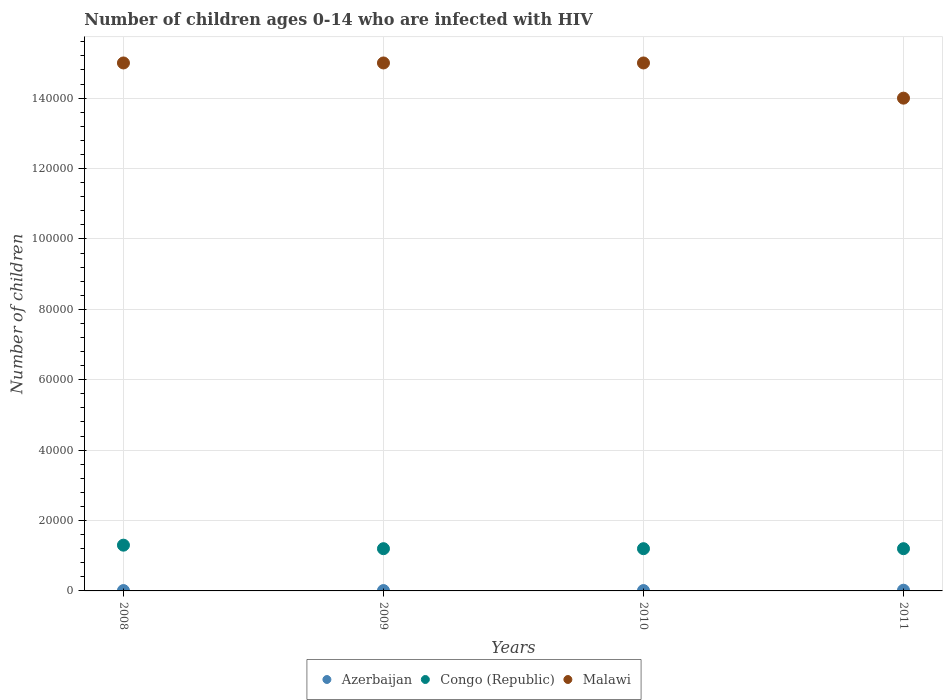What is the number of HIV infected children in Congo (Republic) in 2010?
Provide a succinct answer. 1.20e+04. Across all years, what is the maximum number of HIV infected children in Malawi?
Give a very brief answer. 1.50e+05. Across all years, what is the minimum number of HIV infected children in Congo (Republic)?
Provide a short and direct response. 1.20e+04. In which year was the number of HIV infected children in Congo (Republic) maximum?
Make the answer very short. 2008. In which year was the number of HIV infected children in Malawi minimum?
Provide a short and direct response. 2011. What is the total number of HIV infected children in Malawi in the graph?
Ensure brevity in your answer.  5.90e+05. What is the difference between the number of HIV infected children in Azerbaijan in 2011 and the number of HIV infected children in Malawi in 2010?
Make the answer very short. -1.50e+05. What is the average number of HIV infected children in Azerbaijan per year?
Provide a succinct answer. 125. In the year 2010, what is the difference between the number of HIV infected children in Malawi and number of HIV infected children in Azerbaijan?
Provide a succinct answer. 1.50e+05. What is the ratio of the number of HIV infected children in Malawi in 2009 to that in 2010?
Your response must be concise. 1. Is the number of HIV infected children in Malawi in 2008 less than that in 2010?
Give a very brief answer. No. What is the difference between the highest and the lowest number of HIV infected children in Congo (Republic)?
Provide a short and direct response. 1000. Is it the case that in every year, the sum of the number of HIV infected children in Azerbaijan and number of HIV infected children in Congo (Republic)  is greater than the number of HIV infected children in Malawi?
Give a very brief answer. No. Is the number of HIV infected children in Azerbaijan strictly greater than the number of HIV infected children in Malawi over the years?
Provide a succinct answer. No. How many years are there in the graph?
Offer a very short reply. 4. What is the difference between two consecutive major ticks on the Y-axis?
Your answer should be compact. 2.00e+04. What is the title of the graph?
Keep it short and to the point. Number of children ages 0-14 who are infected with HIV. Does "Equatorial Guinea" appear as one of the legend labels in the graph?
Ensure brevity in your answer.  No. What is the label or title of the X-axis?
Your answer should be compact. Years. What is the label or title of the Y-axis?
Keep it short and to the point. Number of children. What is the Number of children in Azerbaijan in 2008?
Provide a short and direct response. 100. What is the Number of children of Congo (Republic) in 2008?
Your answer should be very brief. 1.30e+04. What is the Number of children of Azerbaijan in 2009?
Keep it short and to the point. 100. What is the Number of children of Congo (Republic) in 2009?
Give a very brief answer. 1.20e+04. What is the Number of children in Azerbaijan in 2010?
Offer a very short reply. 100. What is the Number of children of Congo (Republic) in 2010?
Keep it short and to the point. 1.20e+04. What is the Number of children of Malawi in 2010?
Provide a succinct answer. 1.50e+05. What is the Number of children of Azerbaijan in 2011?
Provide a short and direct response. 200. What is the Number of children in Congo (Republic) in 2011?
Keep it short and to the point. 1.20e+04. Across all years, what is the maximum Number of children in Azerbaijan?
Keep it short and to the point. 200. Across all years, what is the maximum Number of children in Congo (Republic)?
Keep it short and to the point. 1.30e+04. Across all years, what is the maximum Number of children in Malawi?
Your answer should be compact. 1.50e+05. Across all years, what is the minimum Number of children of Azerbaijan?
Give a very brief answer. 100. Across all years, what is the minimum Number of children of Congo (Republic)?
Provide a succinct answer. 1.20e+04. Across all years, what is the minimum Number of children of Malawi?
Your response must be concise. 1.40e+05. What is the total Number of children in Congo (Republic) in the graph?
Make the answer very short. 4.90e+04. What is the total Number of children in Malawi in the graph?
Give a very brief answer. 5.90e+05. What is the difference between the Number of children of Azerbaijan in 2008 and that in 2009?
Ensure brevity in your answer.  0. What is the difference between the Number of children in Malawi in 2008 and that in 2009?
Offer a terse response. 0. What is the difference between the Number of children of Congo (Republic) in 2008 and that in 2010?
Provide a succinct answer. 1000. What is the difference between the Number of children of Malawi in 2008 and that in 2010?
Keep it short and to the point. 0. What is the difference between the Number of children of Azerbaijan in 2008 and that in 2011?
Your response must be concise. -100. What is the difference between the Number of children in Congo (Republic) in 2008 and that in 2011?
Ensure brevity in your answer.  1000. What is the difference between the Number of children of Malawi in 2008 and that in 2011?
Make the answer very short. 10000. What is the difference between the Number of children in Azerbaijan in 2009 and that in 2010?
Offer a terse response. 0. What is the difference between the Number of children in Malawi in 2009 and that in 2010?
Keep it short and to the point. 0. What is the difference between the Number of children of Azerbaijan in 2009 and that in 2011?
Make the answer very short. -100. What is the difference between the Number of children in Congo (Republic) in 2009 and that in 2011?
Provide a short and direct response. 0. What is the difference between the Number of children in Azerbaijan in 2010 and that in 2011?
Provide a succinct answer. -100. What is the difference between the Number of children of Congo (Republic) in 2010 and that in 2011?
Provide a succinct answer. 0. What is the difference between the Number of children in Azerbaijan in 2008 and the Number of children in Congo (Republic) in 2009?
Your answer should be very brief. -1.19e+04. What is the difference between the Number of children in Azerbaijan in 2008 and the Number of children in Malawi in 2009?
Provide a succinct answer. -1.50e+05. What is the difference between the Number of children in Congo (Republic) in 2008 and the Number of children in Malawi in 2009?
Keep it short and to the point. -1.37e+05. What is the difference between the Number of children of Azerbaijan in 2008 and the Number of children of Congo (Republic) in 2010?
Offer a very short reply. -1.19e+04. What is the difference between the Number of children in Azerbaijan in 2008 and the Number of children in Malawi in 2010?
Make the answer very short. -1.50e+05. What is the difference between the Number of children in Congo (Republic) in 2008 and the Number of children in Malawi in 2010?
Keep it short and to the point. -1.37e+05. What is the difference between the Number of children of Azerbaijan in 2008 and the Number of children of Congo (Republic) in 2011?
Make the answer very short. -1.19e+04. What is the difference between the Number of children of Azerbaijan in 2008 and the Number of children of Malawi in 2011?
Your answer should be compact. -1.40e+05. What is the difference between the Number of children in Congo (Republic) in 2008 and the Number of children in Malawi in 2011?
Offer a very short reply. -1.27e+05. What is the difference between the Number of children of Azerbaijan in 2009 and the Number of children of Congo (Republic) in 2010?
Make the answer very short. -1.19e+04. What is the difference between the Number of children in Azerbaijan in 2009 and the Number of children in Malawi in 2010?
Give a very brief answer. -1.50e+05. What is the difference between the Number of children in Congo (Republic) in 2009 and the Number of children in Malawi in 2010?
Ensure brevity in your answer.  -1.38e+05. What is the difference between the Number of children of Azerbaijan in 2009 and the Number of children of Congo (Republic) in 2011?
Keep it short and to the point. -1.19e+04. What is the difference between the Number of children of Azerbaijan in 2009 and the Number of children of Malawi in 2011?
Offer a very short reply. -1.40e+05. What is the difference between the Number of children of Congo (Republic) in 2009 and the Number of children of Malawi in 2011?
Your answer should be compact. -1.28e+05. What is the difference between the Number of children in Azerbaijan in 2010 and the Number of children in Congo (Republic) in 2011?
Your response must be concise. -1.19e+04. What is the difference between the Number of children of Azerbaijan in 2010 and the Number of children of Malawi in 2011?
Your response must be concise. -1.40e+05. What is the difference between the Number of children of Congo (Republic) in 2010 and the Number of children of Malawi in 2011?
Offer a very short reply. -1.28e+05. What is the average Number of children of Azerbaijan per year?
Your answer should be very brief. 125. What is the average Number of children of Congo (Republic) per year?
Give a very brief answer. 1.22e+04. What is the average Number of children in Malawi per year?
Offer a very short reply. 1.48e+05. In the year 2008, what is the difference between the Number of children in Azerbaijan and Number of children in Congo (Republic)?
Keep it short and to the point. -1.29e+04. In the year 2008, what is the difference between the Number of children of Azerbaijan and Number of children of Malawi?
Provide a succinct answer. -1.50e+05. In the year 2008, what is the difference between the Number of children in Congo (Republic) and Number of children in Malawi?
Your response must be concise. -1.37e+05. In the year 2009, what is the difference between the Number of children in Azerbaijan and Number of children in Congo (Republic)?
Your answer should be compact. -1.19e+04. In the year 2009, what is the difference between the Number of children of Azerbaijan and Number of children of Malawi?
Make the answer very short. -1.50e+05. In the year 2009, what is the difference between the Number of children of Congo (Republic) and Number of children of Malawi?
Offer a terse response. -1.38e+05. In the year 2010, what is the difference between the Number of children in Azerbaijan and Number of children in Congo (Republic)?
Offer a terse response. -1.19e+04. In the year 2010, what is the difference between the Number of children of Azerbaijan and Number of children of Malawi?
Your response must be concise. -1.50e+05. In the year 2010, what is the difference between the Number of children in Congo (Republic) and Number of children in Malawi?
Provide a succinct answer. -1.38e+05. In the year 2011, what is the difference between the Number of children in Azerbaijan and Number of children in Congo (Republic)?
Make the answer very short. -1.18e+04. In the year 2011, what is the difference between the Number of children of Azerbaijan and Number of children of Malawi?
Your answer should be compact. -1.40e+05. In the year 2011, what is the difference between the Number of children of Congo (Republic) and Number of children of Malawi?
Your answer should be compact. -1.28e+05. What is the ratio of the Number of children of Azerbaijan in 2008 to that in 2009?
Ensure brevity in your answer.  1. What is the ratio of the Number of children in Congo (Republic) in 2008 to that in 2009?
Make the answer very short. 1.08. What is the ratio of the Number of children of Congo (Republic) in 2008 to that in 2010?
Ensure brevity in your answer.  1.08. What is the ratio of the Number of children of Congo (Republic) in 2008 to that in 2011?
Your answer should be very brief. 1.08. What is the ratio of the Number of children of Malawi in 2008 to that in 2011?
Give a very brief answer. 1.07. What is the ratio of the Number of children of Azerbaijan in 2009 to that in 2011?
Give a very brief answer. 0.5. What is the ratio of the Number of children of Malawi in 2009 to that in 2011?
Provide a succinct answer. 1.07. What is the ratio of the Number of children of Azerbaijan in 2010 to that in 2011?
Make the answer very short. 0.5. What is the ratio of the Number of children in Malawi in 2010 to that in 2011?
Offer a very short reply. 1.07. What is the difference between the highest and the second highest Number of children of Congo (Republic)?
Provide a short and direct response. 1000. What is the difference between the highest and the lowest Number of children in Congo (Republic)?
Offer a terse response. 1000. What is the difference between the highest and the lowest Number of children of Malawi?
Your response must be concise. 10000. 